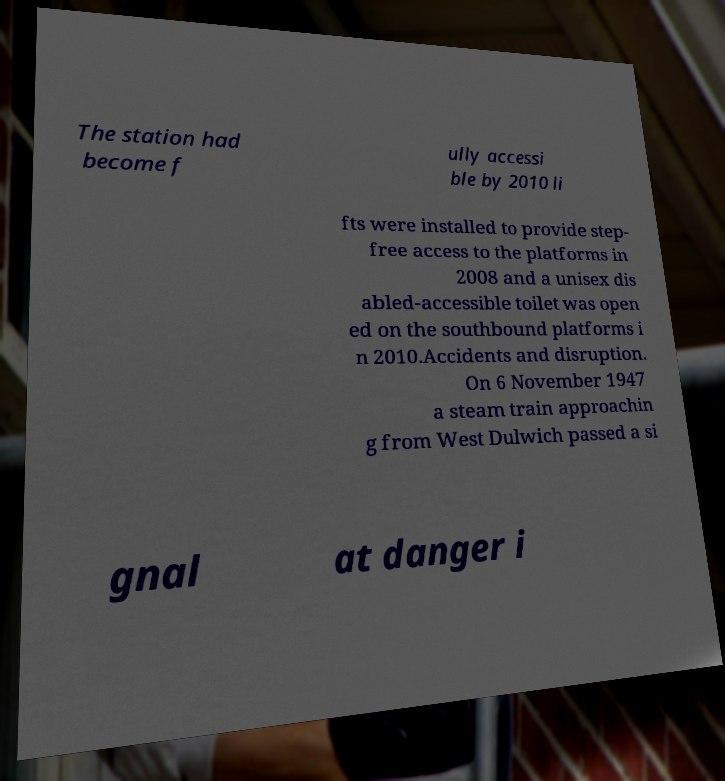Please identify and transcribe the text found in this image. The station had become f ully accessi ble by 2010 li fts were installed to provide step- free access to the platforms in 2008 and a unisex dis abled-accessible toilet was open ed on the southbound platforms i n 2010.Accidents and disruption. On 6 November 1947 a steam train approachin g from West Dulwich passed a si gnal at danger i 